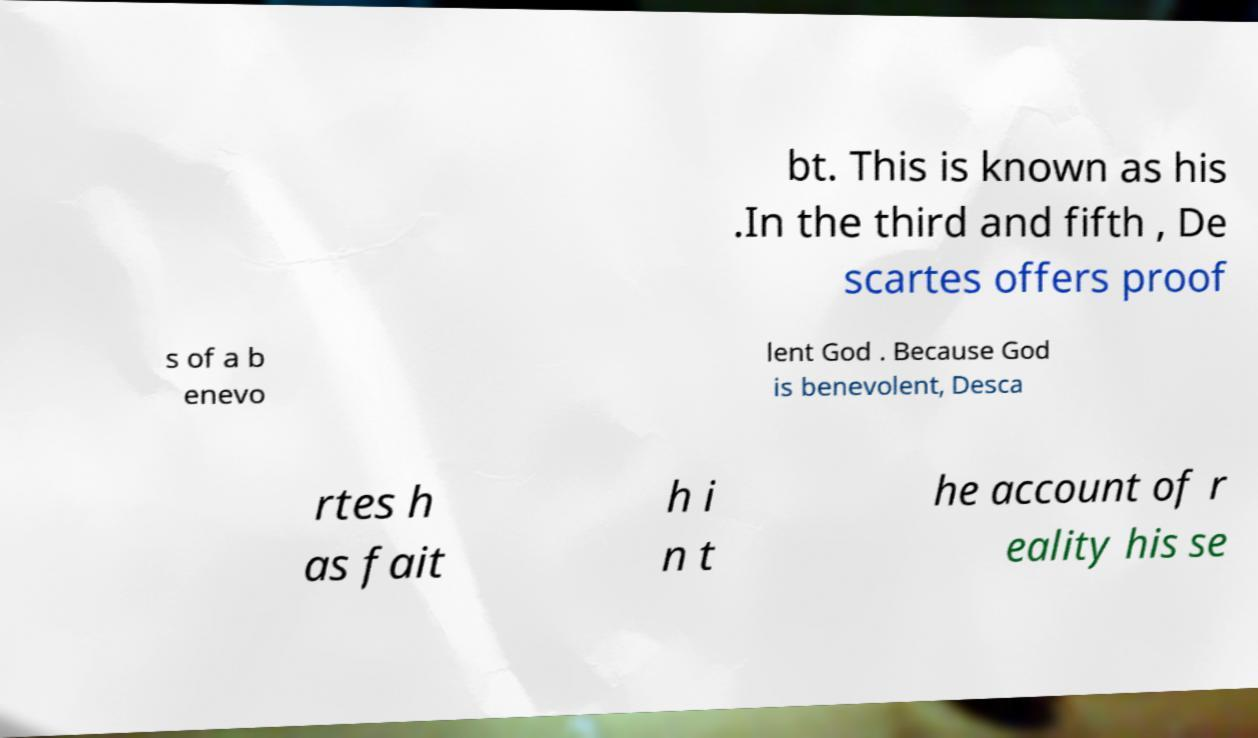Can you accurately transcribe the text from the provided image for me? bt. This is known as his .In the third and fifth , De scartes offers proof s of a b enevo lent God . Because God is benevolent, Desca rtes h as fait h i n t he account of r eality his se 